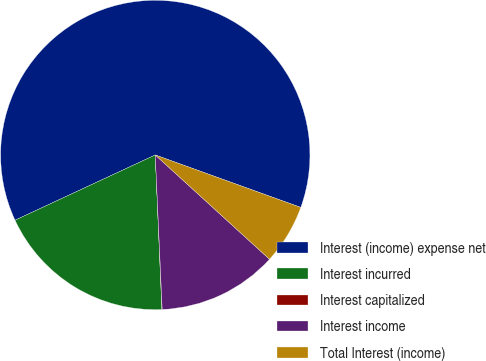Convert chart to OTSL. <chart><loc_0><loc_0><loc_500><loc_500><pie_chart><fcel>Interest (income) expense net<fcel>Interest incurred<fcel>Interest capitalized<fcel>Interest income<fcel>Total Interest (income)<nl><fcel>62.43%<fcel>18.75%<fcel>0.03%<fcel>12.51%<fcel>6.27%<nl></chart> 